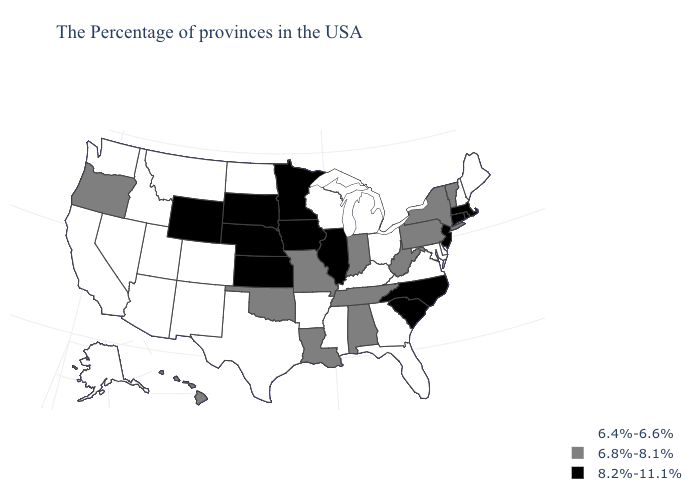Name the states that have a value in the range 6.4%-6.6%?
Quick response, please. Maine, New Hampshire, Delaware, Maryland, Virginia, Ohio, Florida, Georgia, Michigan, Kentucky, Wisconsin, Mississippi, Arkansas, Texas, North Dakota, Colorado, New Mexico, Utah, Montana, Arizona, Idaho, Nevada, California, Washington, Alaska. What is the value of Georgia?
Concise answer only. 6.4%-6.6%. What is the highest value in the Northeast ?
Concise answer only. 8.2%-11.1%. What is the value of Nevada?
Write a very short answer. 6.4%-6.6%. What is the lowest value in the Northeast?
Short answer required. 6.4%-6.6%. What is the highest value in states that border Connecticut?
Short answer required. 8.2%-11.1%. Name the states that have a value in the range 6.8%-8.1%?
Write a very short answer. Vermont, New York, Pennsylvania, West Virginia, Indiana, Alabama, Tennessee, Louisiana, Missouri, Oklahoma, Oregon, Hawaii. What is the value of Connecticut?
Short answer required. 8.2%-11.1%. Does Maine have the highest value in the Northeast?
Give a very brief answer. No. Among the states that border Alabama , which have the lowest value?
Give a very brief answer. Florida, Georgia, Mississippi. Does Connecticut have a lower value than Rhode Island?
Short answer required. No. Does Maine have the highest value in the Northeast?
Write a very short answer. No. What is the value of Oklahoma?
Quick response, please. 6.8%-8.1%. Does the first symbol in the legend represent the smallest category?
Quick response, please. Yes. Among the states that border Delaware , does Maryland have the highest value?
Keep it brief. No. 